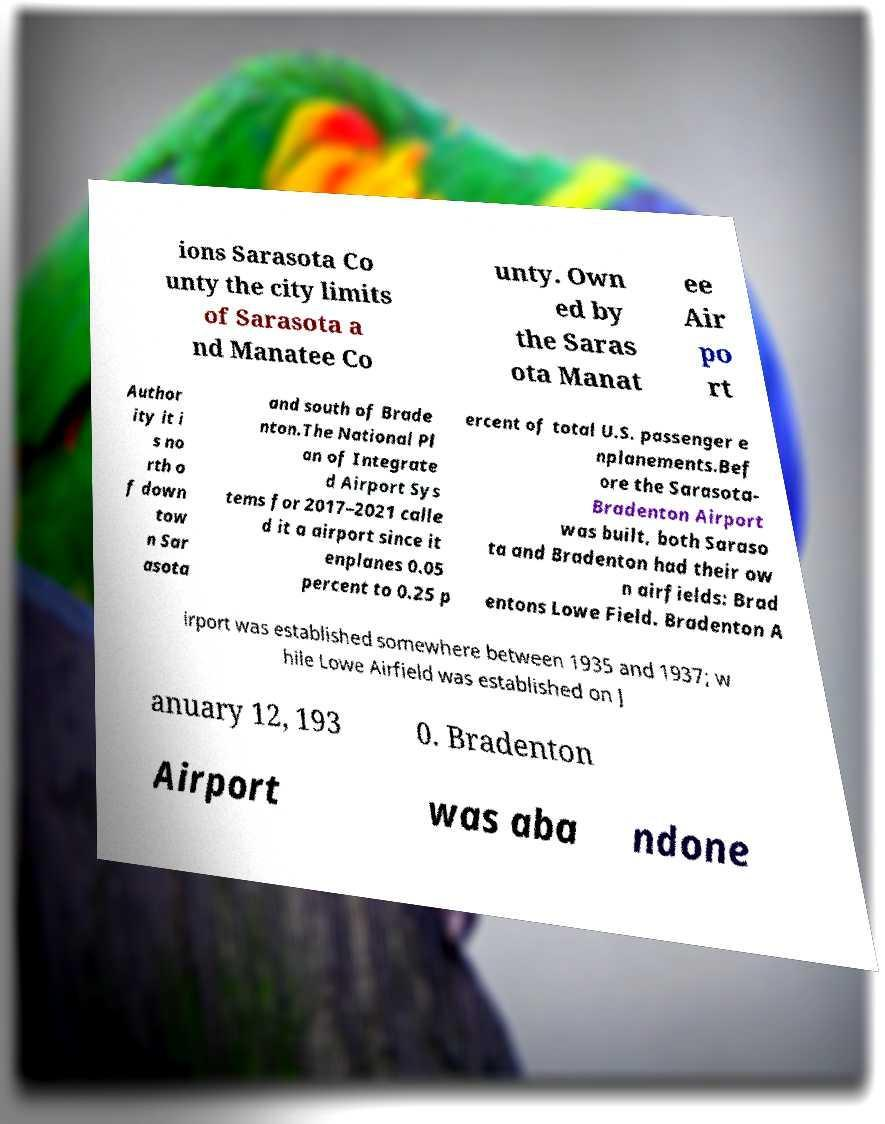Can you accurately transcribe the text from the provided image for me? ions Sarasota Co unty the city limits of Sarasota a nd Manatee Co unty. Own ed by the Saras ota Manat ee Air po rt Author ity it i s no rth o f down tow n Sar asota and south of Brade nton.The National Pl an of Integrate d Airport Sys tems for 2017–2021 calle d it a airport since it enplanes 0.05 percent to 0.25 p ercent of total U.S. passenger e nplanements.Bef ore the Sarasota- Bradenton Airport was built, both Saraso ta and Bradenton had their ow n airfields: Brad entons Lowe Field. Bradenton A irport was established somewhere between 1935 and 1937; w hile Lowe Airfield was established on J anuary 12, 193 0. Bradenton Airport was aba ndone 